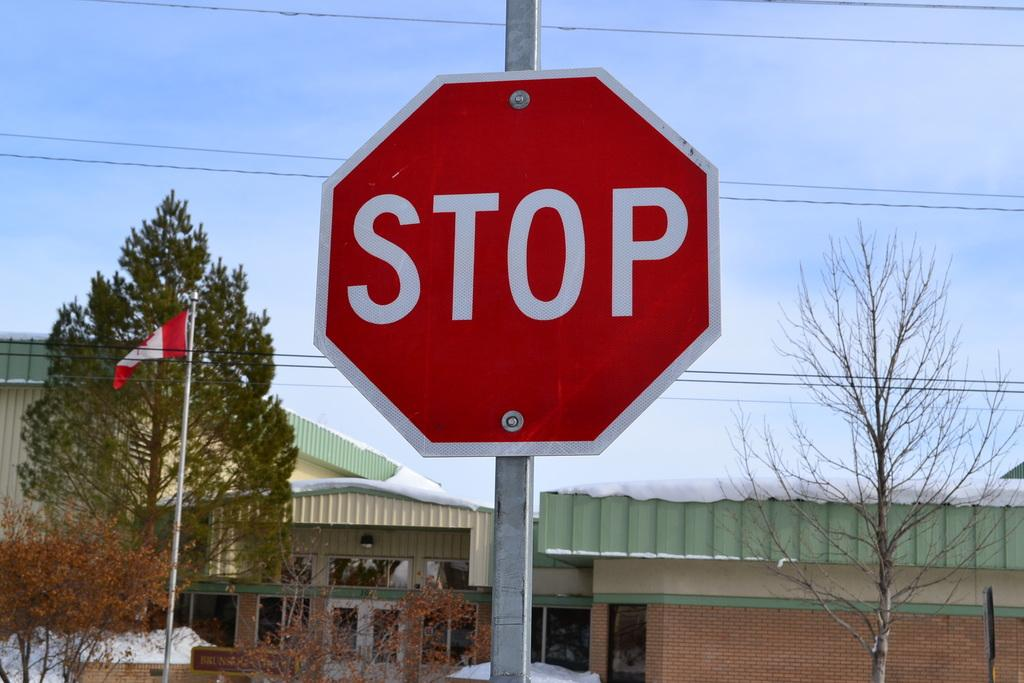<image>
Give a short and clear explanation of the subsequent image. A stop sign in front of a school in Canada. 